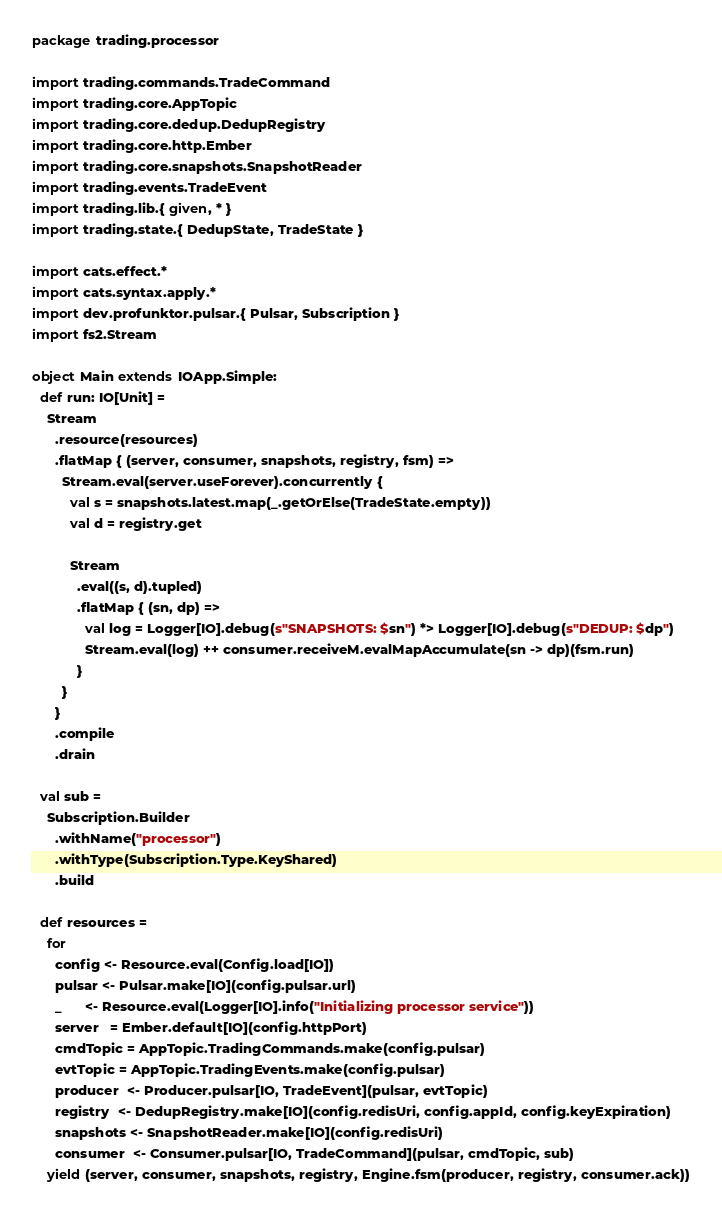<code> <loc_0><loc_0><loc_500><loc_500><_Scala_>package trading.processor

import trading.commands.TradeCommand
import trading.core.AppTopic
import trading.core.dedup.DedupRegistry
import trading.core.http.Ember
import trading.core.snapshots.SnapshotReader
import trading.events.TradeEvent
import trading.lib.{ given, * }
import trading.state.{ DedupState, TradeState }

import cats.effect.*
import cats.syntax.apply.*
import dev.profunktor.pulsar.{ Pulsar, Subscription }
import fs2.Stream

object Main extends IOApp.Simple:
  def run: IO[Unit] =
    Stream
      .resource(resources)
      .flatMap { (server, consumer, snapshots, registry, fsm) =>
        Stream.eval(server.useForever).concurrently {
          val s = snapshots.latest.map(_.getOrElse(TradeState.empty))
          val d = registry.get

          Stream
            .eval((s, d).tupled)
            .flatMap { (sn, dp) =>
              val log = Logger[IO].debug(s"SNAPSHOTS: $sn") *> Logger[IO].debug(s"DEDUP: $dp")
              Stream.eval(log) ++ consumer.receiveM.evalMapAccumulate(sn -> dp)(fsm.run)
            }
        }
      }
      .compile
      .drain

  val sub =
    Subscription.Builder
      .withName("processor")
      .withType(Subscription.Type.KeyShared)
      .build

  def resources =
    for
      config <- Resource.eval(Config.load[IO])
      pulsar <- Pulsar.make[IO](config.pulsar.url)
      _      <- Resource.eval(Logger[IO].info("Initializing processor service"))
      server   = Ember.default[IO](config.httpPort)
      cmdTopic = AppTopic.TradingCommands.make(config.pulsar)
      evtTopic = AppTopic.TradingEvents.make(config.pulsar)
      producer  <- Producer.pulsar[IO, TradeEvent](pulsar, evtTopic)
      registry  <- DedupRegistry.make[IO](config.redisUri, config.appId, config.keyExpiration)
      snapshots <- SnapshotReader.make[IO](config.redisUri)
      consumer  <- Consumer.pulsar[IO, TradeCommand](pulsar, cmdTopic, sub)
    yield (server, consumer, snapshots, registry, Engine.fsm(producer, registry, consumer.ack))
</code> 